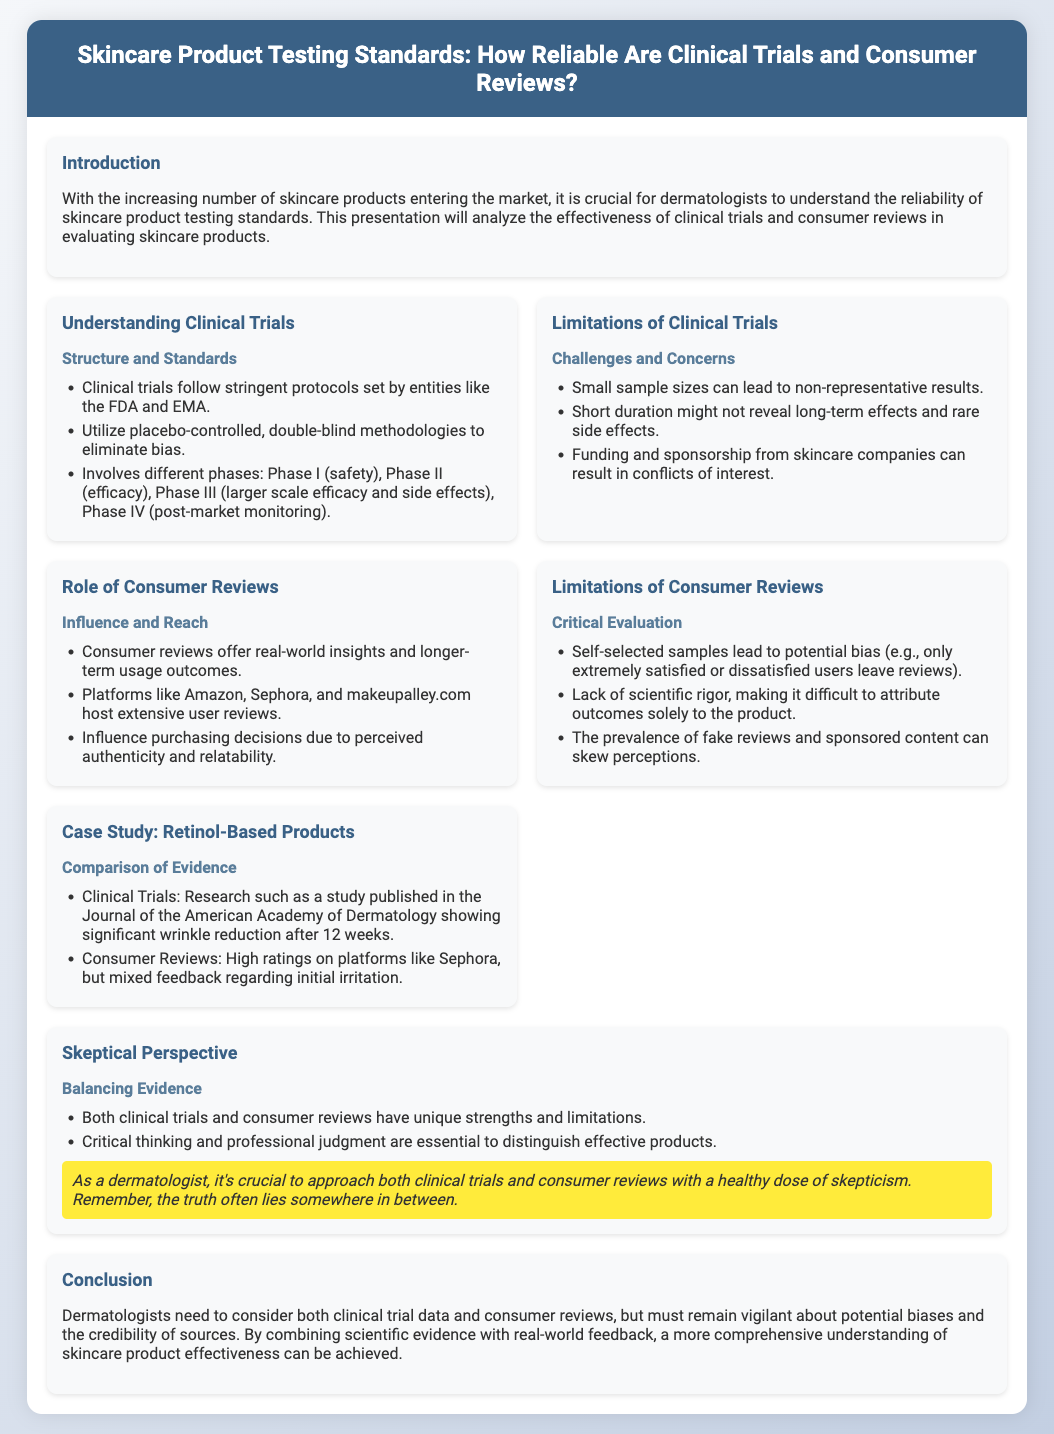What is the main topic of the presentation? The main topic is the reliability of skincare product testing standards, specifically focusing on clinical trials and consumer reviews.
Answer: Skincare Product Testing Standards What methodology do clinical trials utilize to eliminate bias? Clinical trials utilize placebo-controlled, double-blind methodologies to ensure participants and researchers do not know who receives the treatment vs. placebo.
Answer: Placebo-controlled, double-blind What is a limitation of clinical trials mentioned in the document? The document notes that small sample sizes can lead to non-representative results, among other limitations.
Answer: Small sample sizes What platforms are mentioned as hosting extensive consumer reviews? The document lists platforms like Amazon, Sephora, and makeupalley.com as places where users can find reviews.
Answer: Amazon, Sephora, makeupalley.com What is a potential bias in consumer reviews? The document highlights that self-selected samples can lead to bias, as only certain users tend to leave feedback.
Answer: Self-selected samples How many phases are involved in clinical trials according to the presentation? The document outlines four phases, indicating the different stages clinical trials go through from safety testing to post-market monitoring.
Answer: Four phases What is a key factor dermatologists should consider when evaluating products? The presentation emphasizes the importance of combining scientific evidence with real-world feedback to assess product effectiveness.
Answer: Scientific evidence and real-world feedback What case study is mentioned in the presentation? The presentation discusses retinol-based products, comparing clinical trial results with consumer reviews.
Answer: Retinol-Based Products What is emphasized in the skeptical perspective section? The skeptical perspective notes that both clinical trials and consumer reviews have their strengths and limitations, necessitating critical thinking.
Answer: Strengths and limitations 